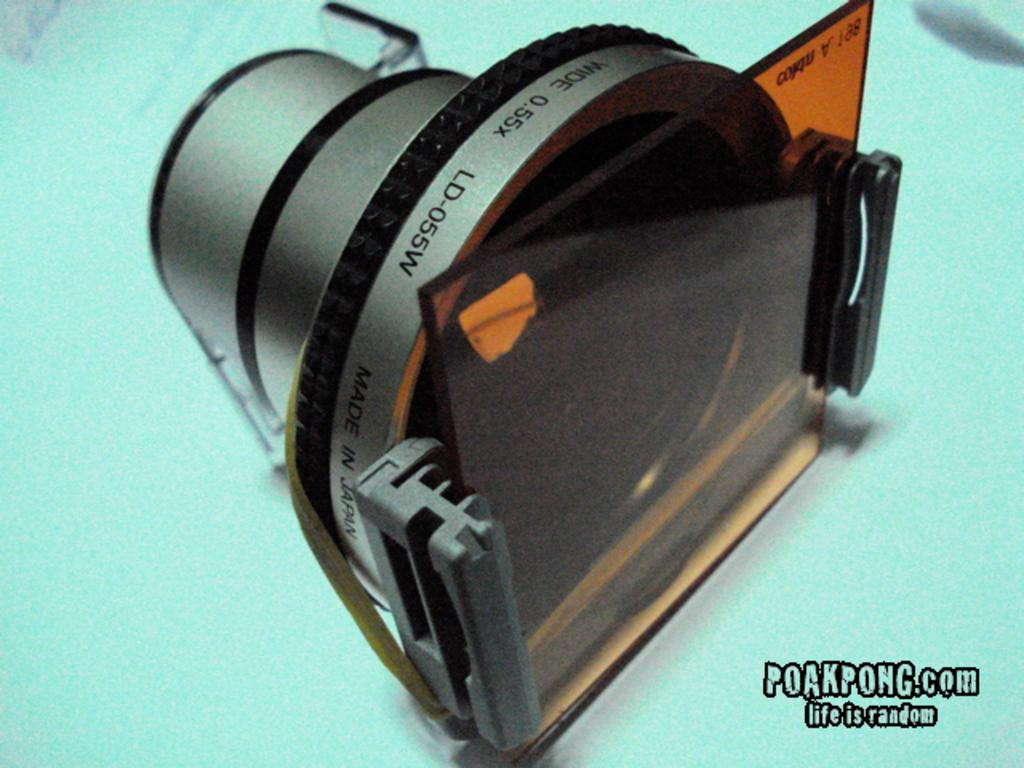What object is the main focus of the image? There is a camera in the image. Where is the camera located? The camera is on a surface. What can be seen on the camera itself? There is text on the camera. What additional text is present in the image? There is edited text in the bottom right-hand corner of the image. Is there a house visible in the image? No, there is no house present in the image. Can you see a bike in the image? No, there is no bike present in the image. 